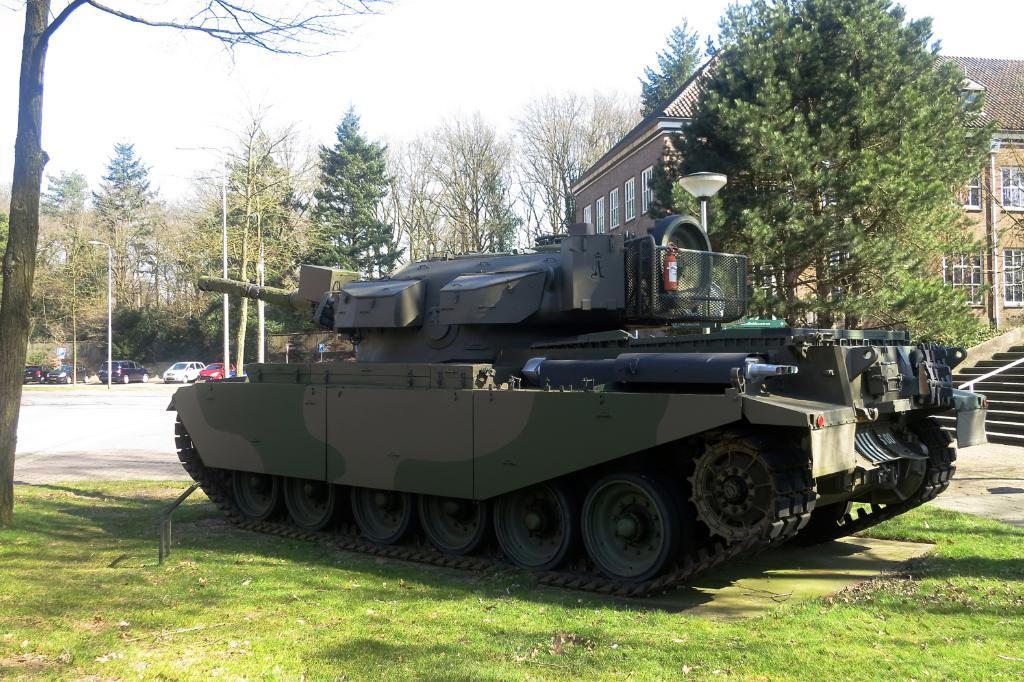What is the main subject of the image? The main subject of the image is a tanker. What other objects or structures can be seen in the image? There are vehicles, light poles, a house, trees, and the sky visible in the image. Can you describe the house in the image? The house has windows and a staircase. What is your aunt's relation to the passenger in the image? There is no information about an aunt or a passenger in the image, so it is not possible to determine their relationship. 